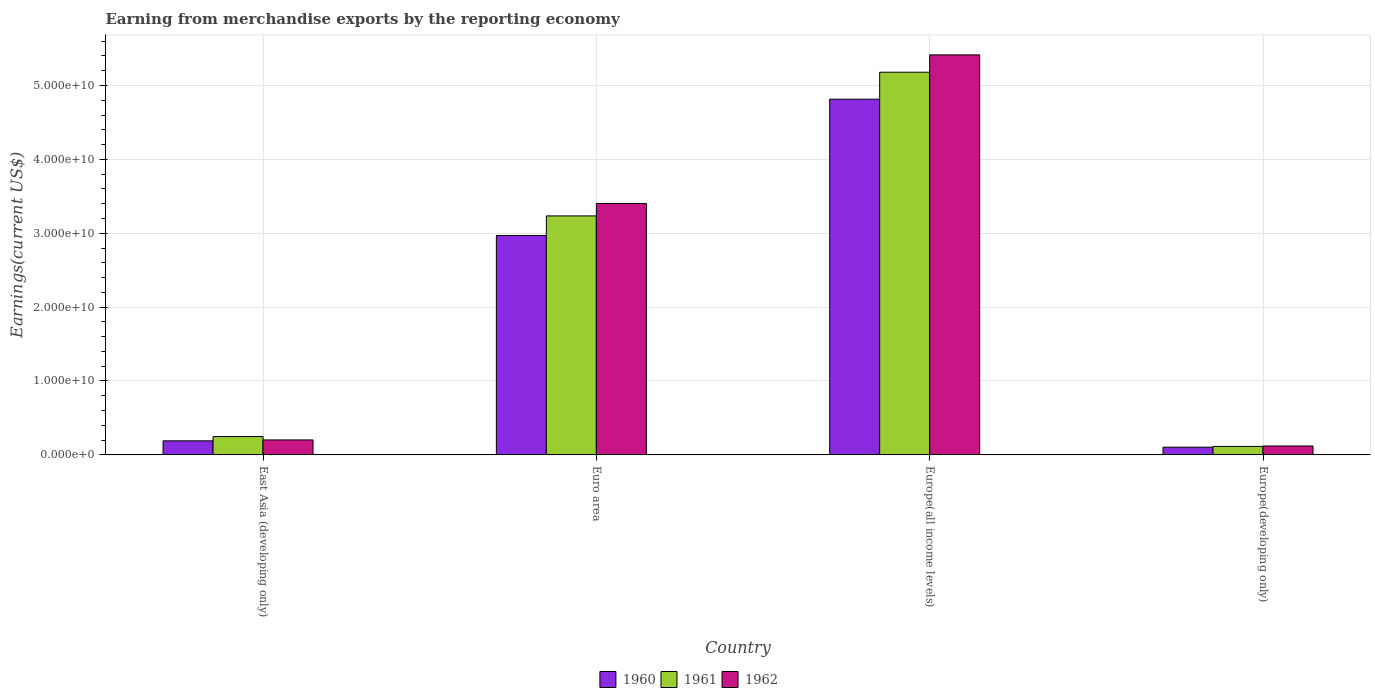How many groups of bars are there?
Provide a succinct answer. 4. How many bars are there on the 1st tick from the left?
Provide a succinct answer. 3. How many bars are there on the 4th tick from the right?
Offer a very short reply. 3. What is the label of the 3rd group of bars from the left?
Your answer should be very brief. Europe(all income levels). What is the amount earned from merchandise exports in 1961 in Europe(developing only)?
Offer a terse response. 1.14e+09. Across all countries, what is the maximum amount earned from merchandise exports in 1960?
Give a very brief answer. 4.82e+1. Across all countries, what is the minimum amount earned from merchandise exports in 1960?
Give a very brief answer. 1.03e+09. In which country was the amount earned from merchandise exports in 1960 maximum?
Provide a short and direct response. Europe(all income levels). In which country was the amount earned from merchandise exports in 1961 minimum?
Your answer should be compact. Europe(developing only). What is the total amount earned from merchandise exports in 1962 in the graph?
Make the answer very short. 9.14e+1. What is the difference between the amount earned from merchandise exports in 1961 in Euro area and that in Europe(developing only)?
Keep it short and to the point. 3.12e+1. What is the difference between the amount earned from merchandise exports in 1960 in Europe(all income levels) and the amount earned from merchandise exports in 1962 in Europe(developing only)?
Make the answer very short. 4.70e+1. What is the average amount earned from merchandise exports in 1960 per country?
Offer a terse response. 2.02e+1. What is the difference between the amount earned from merchandise exports of/in 1961 and amount earned from merchandise exports of/in 1962 in Europe(developing only)?
Your answer should be very brief. -5.88e+07. What is the ratio of the amount earned from merchandise exports in 1962 in Euro area to that in Europe(all income levels)?
Provide a succinct answer. 0.63. Is the difference between the amount earned from merchandise exports in 1961 in Euro area and Europe(all income levels) greater than the difference between the amount earned from merchandise exports in 1962 in Euro area and Europe(all income levels)?
Your answer should be compact. Yes. What is the difference between the highest and the second highest amount earned from merchandise exports in 1960?
Your response must be concise. 4.63e+1. What is the difference between the highest and the lowest amount earned from merchandise exports in 1961?
Offer a terse response. 5.07e+1. In how many countries, is the amount earned from merchandise exports in 1960 greater than the average amount earned from merchandise exports in 1960 taken over all countries?
Your answer should be compact. 2. Is the sum of the amount earned from merchandise exports in 1962 in East Asia (developing only) and Europe(developing only) greater than the maximum amount earned from merchandise exports in 1960 across all countries?
Provide a short and direct response. No. What does the 3rd bar from the right in Europe(developing only) represents?
Your answer should be compact. 1960. Is it the case that in every country, the sum of the amount earned from merchandise exports in 1962 and amount earned from merchandise exports in 1961 is greater than the amount earned from merchandise exports in 1960?
Make the answer very short. Yes. What is the difference between two consecutive major ticks on the Y-axis?
Make the answer very short. 1.00e+1. Does the graph contain grids?
Provide a short and direct response. Yes. How are the legend labels stacked?
Make the answer very short. Horizontal. What is the title of the graph?
Ensure brevity in your answer.  Earning from merchandise exports by the reporting economy. What is the label or title of the X-axis?
Give a very brief answer. Country. What is the label or title of the Y-axis?
Offer a very short reply. Earnings(current US$). What is the Earnings(current US$) of 1960 in East Asia (developing only)?
Keep it short and to the point. 1.89e+09. What is the Earnings(current US$) in 1961 in East Asia (developing only)?
Offer a very short reply. 2.47e+09. What is the Earnings(current US$) in 1962 in East Asia (developing only)?
Your response must be concise. 2.01e+09. What is the Earnings(current US$) in 1960 in Euro area?
Provide a succinct answer. 2.97e+1. What is the Earnings(current US$) in 1961 in Euro area?
Your answer should be very brief. 3.23e+1. What is the Earnings(current US$) of 1962 in Euro area?
Ensure brevity in your answer.  3.40e+1. What is the Earnings(current US$) of 1960 in Europe(all income levels)?
Provide a short and direct response. 4.82e+1. What is the Earnings(current US$) of 1961 in Europe(all income levels)?
Provide a succinct answer. 5.18e+1. What is the Earnings(current US$) of 1962 in Europe(all income levels)?
Make the answer very short. 5.42e+1. What is the Earnings(current US$) in 1960 in Europe(developing only)?
Give a very brief answer. 1.03e+09. What is the Earnings(current US$) of 1961 in Europe(developing only)?
Make the answer very short. 1.14e+09. What is the Earnings(current US$) of 1962 in Europe(developing only)?
Give a very brief answer. 1.19e+09. Across all countries, what is the maximum Earnings(current US$) of 1960?
Keep it short and to the point. 4.82e+1. Across all countries, what is the maximum Earnings(current US$) in 1961?
Give a very brief answer. 5.18e+1. Across all countries, what is the maximum Earnings(current US$) of 1962?
Offer a very short reply. 5.42e+1. Across all countries, what is the minimum Earnings(current US$) of 1960?
Keep it short and to the point. 1.03e+09. Across all countries, what is the minimum Earnings(current US$) of 1961?
Give a very brief answer. 1.14e+09. Across all countries, what is the minimum Earnings(current US$) in 1962?
Provide a succinct answer. 1.19e+09. What is the total Earnings(current US$) in 1960 in the graph?
Offer a very short reply. 8.08e+1. What is the total Earnings(current US$) of 1961 in the graph?
Make the answer very short. 8.78e+1. What is the total Earnings(current US$) of 1962 in the graph?
Your answer should be compact. 9.14e+1. What is the difference between the Earnings(current US$) in 1960 in East Asia (developing only) and that in Euro area?
Give a very brief answer. -2.78e+1. What is the difference between the Earnings(current US$) in 1961 in East Asia (developing only) and that in Euro area?
Your answer should be very brief. -2.99e+1. What is the difference between the Earnings(current US$) of 1962 in East Asia (developing only) and that in Euro area?
Give a very brief answer. -3.20e+1. What is the difference between the Earnings(current US$) of 1960 in East Asia (developing only) and that in Europe(all income levels)?
Give a very brief answer. -4.63e+1. What is the difference between the Earnings(current US$) in 1961 in East Asia (developing only) and that in Europe(all income levels)?
Keep it short and to the point. -4.93e+1. What is the difference between the Earnings(current US$) of 1962 in East Asia (developing only) and that in Europe(all income levels)?
Your answer should be compact. -5.21e+1. What is the difference between the Earnings(current US$) in 1960 in East Asia (developing only) and that in Europe(developing only)?
Provide a succinct answer. 8.58e+08. What is the difference between the Earnings(current US$) in 1961 in East Asia (developing only) and that in Europe(developing only)?
Provide a short and direct response. 1.33e+09. What is the difference between the Earnings(current US$) in 1962 in East Asia (developing only) and that in Europe(developing only)?
Provide a short and direct response. 8.18e+08. What is the difference between the Earnings(current US$) of 1960 in Euro area and that in Europe(all income levels)?
Give a very brief answer. -1.85e+1. What is the difference between the Earnings(current US$) in 1961 in Euro area and that in Europe(all income levels)?
Ensure brevity in your answer.  -1.95e+1. What is the difference between the Earnings(current US$) in 1962 in Euro area and that in Europe(all income levels)?
Offer a terse response. -2.01e+1. What is the difference between the Earnings(current US$) of 1960 in Euro area and that in Europe(developing only)?
Provide a short and direct response. 2.87e+1. What is the difference between the Earnings(current US$) in 1961 in Euro area and that in Europe(developing only)?
Your answer should be compact. 3.12e+1. What is the difference between the Earnings(current US$) of 1962 in Euro area and that in Europe(developing only)?
Give a very brief answer. 3.28e+1. What is the difference between the Earnings(current US$) of 1960 in Europe(all income levels) and that in Europe(developing only)?
Your answer should be compact. 4.71e+1. What is the difference between the Earnings(current US$) in 1961 in Europe(all income levels) and that in Europe(developing only)?
Provide a succinct answer. 5.07e+1. What is the difference between the Earnings(current US$) in 1962 in Europe(all income levels) and that in Europe(developing only)?
Keep it short and to the point. 5.30e+1. What is the difference between the Earnings(current US$) in 1960 in East Asia (developing only) and the Earnings(current US$) in 1961 in Euro area?
Provide a succinct answer. -3.05e+1. What is the difference between the Earnings(current US$) of 1960 in East Asia (developing only) and the Earnings(current US$) of 1962 in Euro area?
Your response must be concise. -3.21e+1. What is the difference between the Earnings(current US$) in 1961 in East Asia (developing only) and the Earnings(current US$) in 1962 in Euro area?
Provide a succinct answer. -3.16e+1. What is the difference between the Earnings(current US$) of 1960 in East Asia (developing only) and the Earnings(current US$) of 1961 in Europe(all income levels)?
Offer a very short reply. -4.99e+1. What is the difference between the Earnings(current US$) of 1960 in East Asia (developing only) and the Earnings(current US$) of 1962 in Europe(all income levels)?
Provide a succinct answer. -5.23e+1. What is the difference between the Earnings(current US$) of 1961 in East Asia (developing only) and the Earnings(current US$) of 1962 in Europe(all income levels)?
Offer a terse response. -5.17e+1. What is the difference between the Earnings(current US$) in 1960 in East Asia (developing only) and the Earnings(current US$) in 1961 in Europe(developing only)?
Keep it short and to the point. 7.54e+08. What is the difference between the Earnings(current US$) of 1960 in East Asia (developing only) and the Earnings(current US$) of 1962 in Europe(developing only)?
Ensure brevity in your answer.  6.95e+08. What is the difference between the Earnings(current US$) of 1961 in East Asia (developing only) and the Earnings(current US$) of 1962 in Europe(developing only)?
Offer a terse response. 1.28e+09. What is the difference between the Earnings(current US$) of 1960 in Euro area and the Earnings(current US$) of 1961 in Europe(all income levels)?
Your response must be concise. -2.21e+1. What is the difference between the Earnings(current US$) of 1960 in Euro area and the Earnings(current US$) of 1962 in Europe(all income levels)?
Ensure brevity in your answer.  -2.45e+1. What is the difference between the Earnings(current US$) in 1961 in Euro area and the Earnings(current US$) in 1962 in Europe(all income levels)?
Offer a terse response. -2.18e+1. What is the difference between the Earnings(current US$) in 1960 in Euro area and the Earnings(current US$) in 1961 in Europe(developing only)?
Provide a succinct answer. 2.86e+1. What is the difference between the Earnings(current US$) of 1960 in Euro area and the Earnings(current US$) of 1962 in Europe(developing only)?
Provide a succinct answer. 2.85e+1. What is the difference between the Earnings(current US$) of 1961 in Euro area and the Earnings(current US$) of 1962 in Europe(developing only)?
Give a very brief answer. 3.12e+1. What is the difference between the Earnings(current US$) in 1960 in Europe(all income levels) and the Earnings(current US$) in 1961 in Europe(developing only)?
Offer a very short reply. 4.70e+1. What is the difference between the Earnings(current US$) in 1960 in Europe(all income levels) and the Earnings(current US$) in 1962 in Europe(developing only)?
Ensure brevity in your answer.  4.70e+1. What is the difference between the Earnings(current US$) in 1961 in Europe(all income levels) and the Earnings(current US$) in 1962 in Europe(developing only)?
Your answer should be compact. 5.06e+1. What is the average Earnings(current US$) in 1960 per country?
Offer a terse response. 2.02e+1. What is the average Earnings(current US$) in 1961 per country?
Ensure brevity in your answer.  2.19e+1. What is the average Earnings(current US$) in 1962 per country?
Make the answer very short. 2.28e+1. What is the difference between the Earnings(current US$) in 1960 and Earnings(current US$) in 1961 in East Asia (developing only)?
Offer a very short reply. -5.80e+08. What is the difference between the Earnings(current US$) of 1960 and Earnings(current US$) of 1962 in East Asia (developing only)?
Provide a succinct answer. -1.22e+08. What is the difference between the Earnings(current US$) of 1961 and Earnings(current US$) of 1962 in East Asia (developing only)?
Ensure brevity in your answer.  4.57e+08. What is the difference between the Earnings(current US$) in 1960 and Earnings(current US$) in 1961 in Euro area?
Give a very brief answer. -2.65e+09. What is the difference between the Earnings(current US$) of 1960 and Earnings(current US$) of 1962 in Euro area?
Your answer should be very brief. -4.33e+09. What is the difference between the Earnings(current US$) in 1961 and Earnings(current US$) in 1962 in Euro area?
Your answer should be compact. -1.68e+09. What is the difference between the Earnings(current US$) of 1960 and Earnings(current US$) of 1961 in Europe(all income levels)?
Give a very brief answer. -3.65e+09. What is the difference between the Earnings(current US$) of 1960 and Earnings(current US$) of 1962 in Europe(all income levels)?
Your answer should be very brief. -6.00e+09. What is the difference between the Earnings(current US$) in 1961 and Earnings(current US$) in 1962 in Europe(all income levels)?
Provide a short and direct response. -2.35e+09. What is the difference between the Earnings(current US$) in 1960 and Earnings(current US$) in 1961 in Europe(developing only)?
Your answer should be compact. -1.04e+08. What is the difference between the Earnings(current US$) in 1960 and Earnings(current US$) in 1962 in Europe(developing only)?
Your answer should be compact. -1.62e+08. What is the difference between the Earnings(current US$) of 1961 and Earnings(current US$) of 1962 in Europe(developing only)?
Give a very brief answer. -5.88e+07. What is the ratio of the Earnings(current US$) in 1960 in East Asia (developing only) to that in Euro area?
Offer a very short reply. 0.06. What is the ratio of the Earnings(current US$) of 1961 in East Asia (developing only) to that in Euro area?
Provide a short and direct response. 0.08. What is the ratio of the Earnings(current US$) in 1962 in East Asia (developing only) to that in Euro area?
Ensure brevity in your answer.  0.06. What is the ratio of the Earnings(current US$) of 1960 in East Asia (developing only) to that in Europe(all income levels)?
Offer a terse response. 0.04. What is the ratio of the Earnings(current US$) in 1961 in East Asia (developing only) to that in Europe(all income levels)?
Keep it short and to the point. 0.05. What is the ratio of the Earnings(current US$) of 1962 in East Asia (developing only) to that in Europe(all income levels)?
Provide a short and direct response. 0.04. What is the ratio of the Earnings(current US$) in 1960 in East Asia (developing only) to that in Europe(developing only)?
Your answer should be compact. 1.83. What is the ratio of the Earnings(current US$) of 1961 in East Asia (developing only) to that in Europe(developing only)?
Your answer should be compact. 2.18. What is the ratio of the Earnings(current US$) of 1962 in East Asia (developing only) to that in Europe(developing only)?
Offer a very short reply. 1.68. What is the ratio of the Earnings(current US$) in 1960 in Euro area to that in Europe(all income levels)?
Provide a succinct answer. 0.62. What is the ratio of the Earnings(current US$) of 1961 in Euro area to that in Europe(all income levels)?
Keep it short and to the point. 0.62. What is the ratio of the Earnings(current US$) in 1962 in Euro area to that in Europe(all income levels)?
Give a very brief answer. 0.63. What is the ratio of the Earnings(current US$) in 1960 in Euro area to that in Europe(developing only)?
Provide a succinct answer. 28.78. What is the ratio of the Earnings(current US$) of 1961 in Euro area to that in Europe(developing only)?
Give a very brief answer. 28.49. What is the ratio of the Earnings(current US$) in 1962 in Euro area to that in Europe(developing only)?
Make the answer very short. 28.49. What is the ratio of the Earnings(current US$) in 1960 in Europe(all income levels) to that in Europe(developing only)?
Offer a terse response. 46.67. What is the ratio of the Earnings(current US$) in 1961 in Europe(all income levels) to that in Europe(developing only)?
Provide a short and direct response. 45.63. What is the ratio of the Earnings(current US$) in 1962 in Europe(all income levels) to that in Europe(developing only)?
Provide a succinct answer. 45.35. What is the difference between the highest and the second highest Earnings(current US$) of 1960?
Offer a very short reply. 1.85e+1. What is the difference between the highest and the second highest Earnings(current US$) in 1961?
Make the answer very short. 1.95e+1. What is the difference between the highest and the second highest Earnings(current US$) of 1962?
Ensure brevity in your answer.  2.01e+1. What is the difference between the highest and the lowest Earnings(current US$) of 1960?
Your answer should be very brief. 4.71e+1. What is the difference between the highest and the lowest Earnings(current US$) of 1961?
Your response must be concise. 5.07e+1. What is the difference between the highest and the lowest Earnings(current US$) of 1962?
Keep it short and to the point. 5.30e+1. 